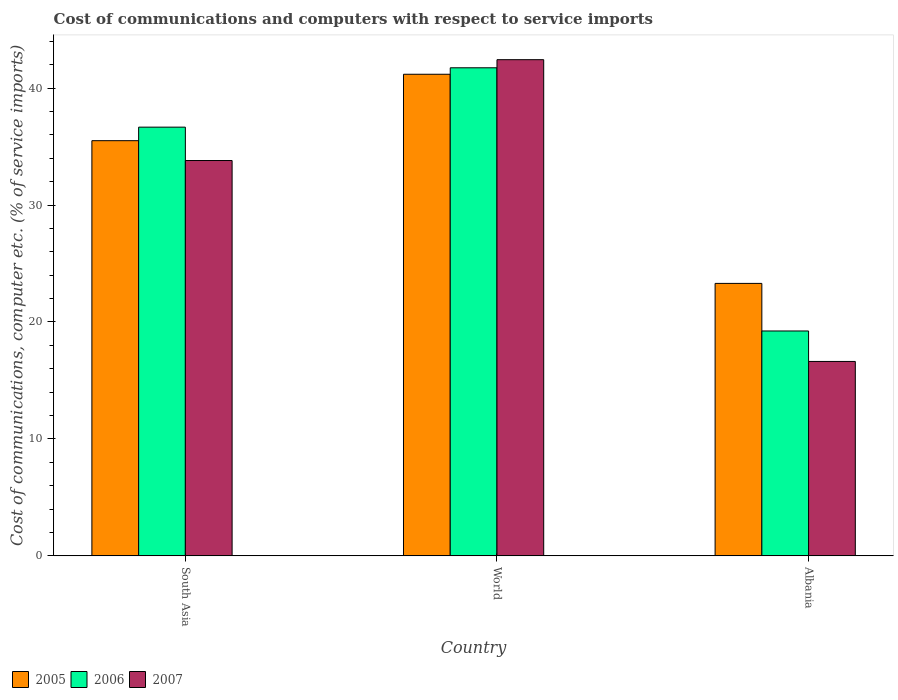How many different coloured bars are there?
Your answer should be compact. 3. How many groups of bars are there?
Provide a short and direct response. 3. How many bars are there on the 3rd tick from the left?
Provide a succinct answer. 3. What is the label of the 3rd group of bars from the left?
Your answer should be compact. Albania. What is the cost of communications and computers in 2005 in South Asia?
Make the answer very short. 35.5. Across all countries, what is the maximum cost of communications and computers in 2007?
Offer a very short reply. 42.43. Across all countries, what is the minimum cost of communications and computers in 2006?
Offer a terse response. 19.23. In which country was the cost of communications and computers in 2007 maximum?
Ensure brevity in your answer.  World. In which country was the cost of communications and computers in 2005 minimum?
Keep it short and to the point. Albania. What is the total cost of communications and computers in 2007 in the graph?
Make the answer very short. 92.86. What is the difference between the cost of communications and computers in 2007 in Albania and that in South Asia?
Ensure brevity in your answer.  -17.18. What is the difference between the cost of communications and computers in 2007 in World and the cost of communications and computers in 2006 in South Asia?
Ensure brevity in your answer.  5.77. What is the average cost of communications and computers in 2006 per country?
Ensure brevity in your answer.  32.54. What is the difference between the cost of communications and computers of/in 2005 and cost of communications and computers of/in 2006 in South Asia?
Your response must be concise. -1.16. In how many countries, is the cost of communications and computers in 2006 greater than 30 %?
Your answer should be very brief. 2. What is the ratio of the cost of communications and computers in 2006 in Albania to that in World?
Ensure brevity in your answer.  0.46. Is the cost of communications and computers in 2006 in Albania less than that in World?
Offer a very short reply. Yes. What is the difference between the highest and the second highest cost of communications and computers in 2006?
Provide a short and direct response. 22.51. What is the difference between the highest and the lowest cost of communications and computers in 2007?
Provide a succinct answer. 25.8. In how many countries, is the cost of communications and computers in 2005 greater than the average cost of communications and computers in 2005 taken over all countries?
Give a very brief answer. 2. Are all the bars in the graph horizontal?
Your answer should be very brief. No. How many countries are there in the graph?
Your response must be concise. 3. What is the difference between two consecutive major ticks on the Y-axis?
Offer a very short reply. 10. Are the values on the major ticks of Y-axis written in scientific E-notation?
Offer a very short reply. No. Does the graph contain any zero values?
Provide a succinct answer. No. Does the graph contain grids?
Your response must be concise. No. Where does the legend appear in the graph?
Provide a succinct answer. Bottom left. How are the legend labels stacked?
Ensure brevity in your answer.  Horizontal. What is the title of the graph?
Keep it short and to the point. Cost of communications and computers with respect to service imports. Does "1997" appear as one of the legend labels in the graph?
Your answer should be very brief. No. What is the label or title of the Y-axis?
Your response must be concise. Cost of communications, computer etc. (% of service imports). What is the Cost of communications, computer etc. (% of service imports) in 2005 in South Asia?
Make the answer very short. 35.5. What is the Cost of communications, computer etc. (% of service imports) in 2006 in South Asia?
Provide a short and direct response. 36.66. What is the Cost of communications, computer etc. (% of service imports) of 2007 in South Asia?
Keep it short and to the point. 33.8. What is the Cost of communications, computer etc. (% of service imports) in 2005 in World?
Your answer should be very brief. 41.18. What is the Cost of communications, computer etc. (% of service imports) of 2006 in World?
Make the answer very short. 41.73. What is the Cost of communications, computer etc. (% of service imports) of 2007 in World?
Offer a very short reply. 42.43. What is the Cost of communications, computer etc. (% of service imports) in 2005 in Albania?
Make the answer very short. 23.3. What is the Cost of communications, computer etc. (% of service imports) in 2006 in Albania?
Ensure brevity in your answer.  19.23. What is the Cost of communications, computer etc. (% of service imports) in 2007 in Albania?
Your answer should be very brief. 16.62. Across all countries, what is the maximum Cost of communications, computer etc. (% of service imports) in 2005?
Your response must be concise. 41.18. Across all countries, what is the maximum Cost of communications, computer etc. (% of service imports) of 2006?
Your response must be concise. 41.73. Across all countries, what is the maximum Cost of communications, computer etc. (% of service imports) of 2007?
Your answer should be very brief. 42.43. Across all countries, what is the minimum Cost of communications, computer etc. (% of service imports) of 2005?
Make the answer very short. 23.3. Across all countries, what is the minimum Cost of communications, computer etc. (% of service imports) of 2006?
Ensure brevity in your answer.  19.23. Across all countries, what is the minimum Cost of communications, computer etc. (% of service imports) of 2007?
Your answer should be compact. 16.62. What is the total Cost of communications, computer etc. (% of service imports) of 2005 in the graph?
Ensure brevity in your answer.  99.98. What is the total Cost of communications, computer etc. (% of service imports) of 2006 in the graph?
Your response must be concise. 97.62. What is the total Cost of communications, computer etc. (% of service imports) of 2007 in the graph?
Offer a very short reply. 92.86. What is the difference between the Cost of communications, computer etc. (% of service imports) in 2005 in South Asia and that in World?
Your answer should be compact. -5.68. What is the difference between the Cost of communications, computer etc. (% of service imports) of 2006 in South Asia and that in World?
Your answer should be very brief. -5.08. What is the difference between the Cost of communications, computer etc. (% of service imports) of 2007 in South Asia and that in World?
Your answer should be compact. -8.62. What is the difference between the Cost of communications, computer etc. (% of service imports) in 2005 in South Asia and that in Albania?
Provide a succinct answer. 12.2. What is the difference between the Cost of communications, computer etc. (% of service imports) in 2006 in South Asia and that in Albania?
Your response must be concise. 17.43. What is the difference between the Cost of communications, computer etc. (% of service imports) in 2007 in South Asia and that in Albania?
Ensure brevity in your answer.  17.18. What is the difference between the Cost of communications, computer etc. (% of service imports) of 2005 in World and that in Albania?
Offer a very short reply. 17.88. What is the difference between the Cost of communications, computer etc. (% of service imports) of 2006 in World and that in Albania?
Offer a terse response. 22.51. What is the difference between the Cost of communications, computer etc. (% of service imports) in 2007 in World and that in Albania?
Provide a short and direct response. 25.8. What is the difference between the Cost of communications, computer etc. (% of service imports) of 2005 in South Asia and the Cost of communications, computer etc. (% of service imports) of 2006 in World?
Your answer should be compact. -6.23. What is the difference between the Cost of communications, computer etc. (% of service imports) of 2005 in South Asia and the Cost of communications, computer etc. (% of service imports) of 2007 in World?
Your response must be concise. -6.93. What is the difference between the Cost of communications, computer etc. (% of service imports) of 2006 in South Asia and the Cost of communications, computer etc. (% of service imports) of 2007 in World?
Keep it short and to the point. -5.77. What is the difference between the Cost of communications, computer etc. (% of service imports) in 2005 in South Asia and the Cost of communications, computer etc. (% of service imports) in 2006 in Albania?
Your answer should be compact. 16.27. What is the difference between the Cost of communications, computer etc. (% of service imports) of 2005 in South Asia and the Cost of communications, computer etc. (% of service imports) of 2007 in Albania?
Ensure brevity in your answer.  18.88. What is the difference between the Cost of communications, computer etc. (% of service imports) in 2006 in South Asia and the Cost of communications, computer etc. (% of service imports) in 2007 in Albania?
Provide a succinct answer. 20.04. What is the difference between the Cost of communications, computer etc. (% of service imports) of 2005 in World and the Cost of communications, computer etc. (% of service imports) of 2006 in Albania?
Your answer should be compact. 21.95. What is the difference between the Cost of communications, computer etc. (% of service imports) in 2005 in World and the Cost of communications, computer etc. (% of service imports) in 2007 in Albania?
Provide a short and direct response. 24.56. What is the difference between the Cost of communications, computer etc. (% of service imports) in 2006 in World and the Cost of communications, computer etc. (% of service imports) in 2007 in Albania?
Give a very brief answer. 25.11. What is the average Cost of communications, computer etc. (% of service imports) of 2005 per country?
Your answer should be very brief. 33.33. What is the average Cost of communications, computer etc. (% of service imports) of 2006 per country?
Offer a terse response. 32.54. What is the average Cost of communications, computer etc. (% of service imports) of 2007 per country?
Offer a terse response. 30.95. What is the difference between the Cost of communications, computer etc. (% of service imports) in 2005 and Cost of communications, computer etc. (% of service imports) in 2006 in South Asia?
Your response must be concise. -1.16. What is the difference between the Cost of communications, computer etc. (% of service imports) in 2005 and Cost of communications, computer etc. (% of service imports) in 2007 in South Asia?
Offer a terse response. 1.7. What is the difference between the Cost of communications, computer etc. (% of service imports) in 2006 and Cost of communications, computer etc. (% of service imports) in 2007 in South Asia?
Keep it short and to the point. 2.86. What is the difference between the Cost of communications, computer etc. (% of service imports) of 2005 and Cost of communications, computer etc. (% of service imports) of 2006 in World?
Your answer should be compact. -0.55. What is the difference between the Cost of communications, computer etc. (% of service imports) in 2005 and Cost of communications, computer etc. (% of service imports) in 2007 in World?
Offer a very short reply. -1.25. What is the difference between the Cost of communications, computer etc. (% of service imports) of 2006 and Cost of communications, computer etc. (% of service imports) of 2007 in World?
Make the answer very short. -0.69. What is the difference between the Cost of communications, computer etc. (% of service imports) of 2005 and Cost of communications, computer etc. (% of service imports) of 2006 in Albania?
Keep it short and to the point. 4.07. What is the difference between the Cost of communications, computer etc. (% of service imports) in 2005 and Cost of communications, computer etc. (% of service imports) in 2007 in Albania?
Keep it short and to the point. 6.67. What is the difference between the Cost of communications, computer etc. (% of service imports) of 2006 and Cost of communications, computer etc. (% of service imports) of 2007 in Albania?
Your response must be concise. 2.6. What is the ratio of the Cost of communications, computer etc. (% of service imports) in 2005 in South Asia to that in World?
Offer a terse response. 0.86. What is the ratio of the Cost of communications, computer etc. (% of service imports) of 2006 in South Asia to that in World?
Give a very brief answer. 0.88. What is the ratio of the Cost of communications, computer etc. (% of service imports) in 2007 in South Asia to that in World?
Give a very brief answer. 0.8. What is the ratio of the Cost of communications, computer etc. (% of service imports) in 2005 in South Asia to that in Albania?
Your response must be concise. 1.52. What is the ratio of the Cost of communications, computer etc. (% of service imports) of 2006 in South Asia to that in Albania?
Offer a very short reply. 1.91. What is the ratio of the Cost of communications, computer etc. (% of service imports) of 2007 in South Asia to that in Albania?
Your answer should be very brief. 2.03. What is the ratio of the Cost of communications, computer etc. (% of service imports) of 2005 in World to that in Albania?
Make the answer very short. 1.77. What is the ratio of the Cost of communications, computer etc. (% of service imports) of 2006 in World to that in Albania?
Ensure brevity in your answer.  2.17. What is the ratio of the Cost of communications, computer etc. (% of service imports) of 2007 in World to that in Albania?
Your answer should be very brief. 2.55. What is the difference between the highest and the second highest Cost of communications, computer etc. (% of service imports) in 2005?
Ensure brevity in your answer.  5.68. What is the difference between the highest and the second highest Cost of communications, computer etc. (% of service imports) of 2006?
Make the answer very short. 5.08. What is the difference between the highest and the second highest Cost of communications, computer etc. (% of service imports) in 2007?
Keep it short and to the point. 8.62. What is the difference between the highest and the lowest Cost of communications, computer etc. (% of service imports) in 2005?
Your answer should be compact. 17.88. What is the difference between the highest and the lowest Cost of communications, computer etc. (% of service imports) in 2006?
Offer a very short reply. 22.51. What is the difference between the highest and the lowest Cost of communications, computer etc. (% of service imports) of 2007?
Give a very brief answer. 25.8. 